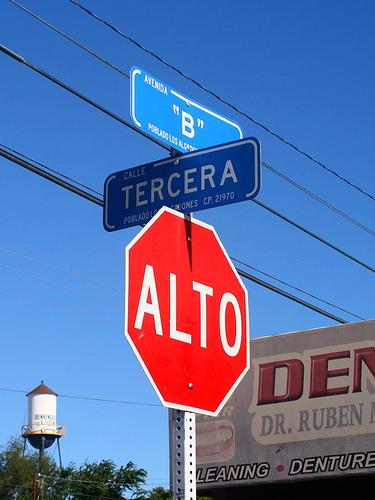What is the sentiment conveyed by the sky in the image? The sentiment conveyed by the sky is a lovely clear blue. What type of sign is being described, and in which language, when it is mentioned as "alto"? "Alto" refers to a stop sign and is written in Spanish. Describe the post that the street signs are attached to. The post is grey and the signs are attached to it. What is the background element described in the image, and what are its colors? A water tower is the background element, and its colors are white and brown. Explain the meaning of 'calle' and what language it comes from. 'Calle' means 'street' in Spanish. Determine the total number of letters involved in the store sign. There is a total of 39 letters involved in the store sign. Identify the color of the street sign with letter 'a' on it and the language it's written in. The street sign with letter 'a' is red and white, and it's written in Spanish. How many objects in the image are specifically described as dark or black colored? Five objects are specifically described as dark or black colored in the image, all of them being power lines. What kind of advertisement is mentioned in the image, and what is the name of the dentist? A billboard advertising a dentist is mentioned, and the dentist's first name is Ruben. Count the number of letters mentioned on the store sign and describe the color of the letters. There are 10 letters mentioned on the store sign, and their color is red. Identify the orange cat sitting on the store sign and determine if it appears to be a stray or a pet. No, it's not mentioned in the image. Generate a description for the signs in the image, mentioning their color and what they convey.  There are red and blue street signs, the red one says "Alto" which is Spanish for stop, and the blue ones indicate B Avenue or Tercera street. Extract the text from the store sign and translate it into English if necessary. There is no need to translate the text, it advertises a dentist named Ruben. Identify any diagrams in the image and describe their purpose. There are no diagrams in the image. Select the suitable phrase for the sky that is portrayed in the image. the sky is a lovely clear blue Infer an activity that may take place in this area based on the objects present in the image. Walking or driving and stopping at the intersection. Identify the type of establishment being advertised in the store sign and the name of the person related to it. A dentist named Ruben is being advertised in the store sign. Provide a description of the blue street signs present in the image. The blue street signs have white lettering and indicate B Avenue, called Tercera in Spanish. Provide a short poem about the scene captured in the image. In the land where Spanish is spoken, Which of the following best represents the image's contents? A) Children playing in a park B) City skyline C) Street signs at an intersection D) A car accident C) Street signs at an intersection Describe the red street sign in the image. The red street sign is a stop sign written in Spanish, saying "Alto." Compose a news headline inspired by the elements in the image. "Red and Blue Street Signs Guide Bilingual Pedestrians Along Colorful City Streets" What language is used for the stop sign in the image? Spanish Determine an event taking place in the image based on the given information. No specific event can be determined from the information. What action can you infer based on the presence and content of the street signs? Stopping at the intersection of B avenue and Tercera street. Create a short story using the elements present in the image. On a sunny day with a lovely clear blue sky, a pedestrian was walking down the street in a Spanish-speaking town. As she passed the water tower, she noticed the red and blue street signs: "Alto" for stop and others for B Avenue and Tercera street. She then saw a billboard advertising a dentist named Ruben. 